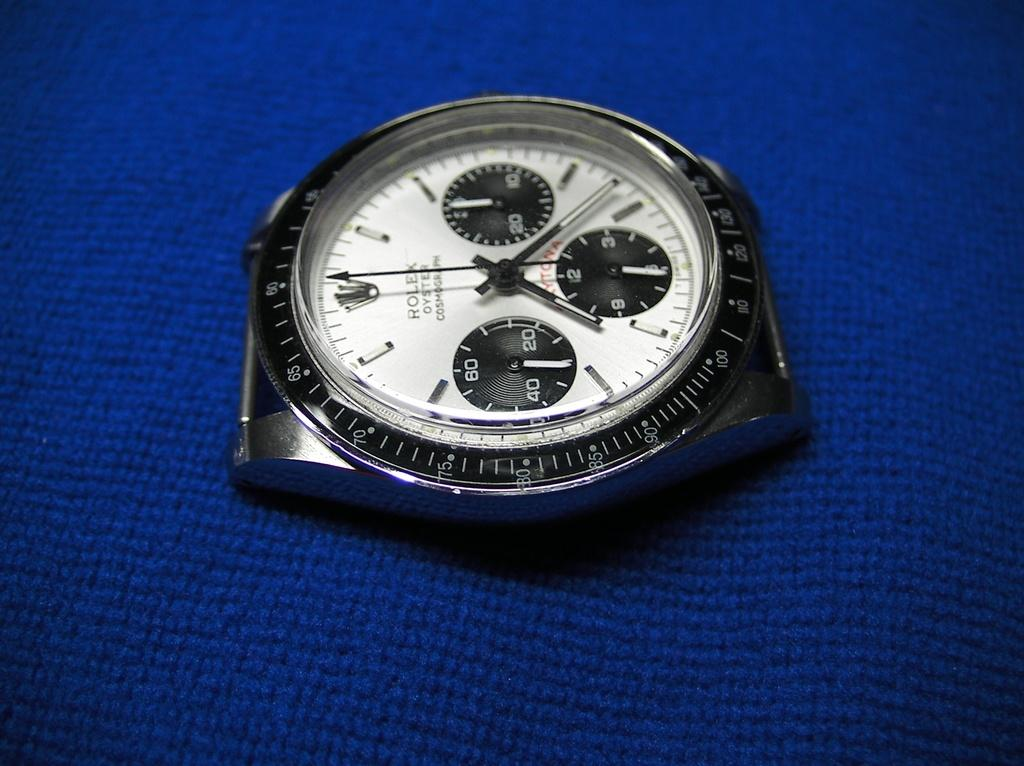What is there is an object in the image that is used for telling time. What is it? There is a wrist watch in the image that is used for telling time. What is the color of the surface on which the wrist watch is placed? The wrist watch is on a blue color surface. What type of door can be seen in the image? There is no door present in the image; it only features a wrist watch on a blue color surface. 